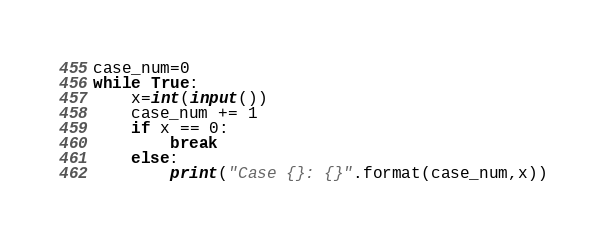<code> <loc_0><loc_0><loc_500><loc_500><_Python_>case_num=0
while True:
    x=int(input())
    case_num += 1
    if x == 0:
        break
    else:
        print("Case {}: {}".format(case_num,x))
</code> 